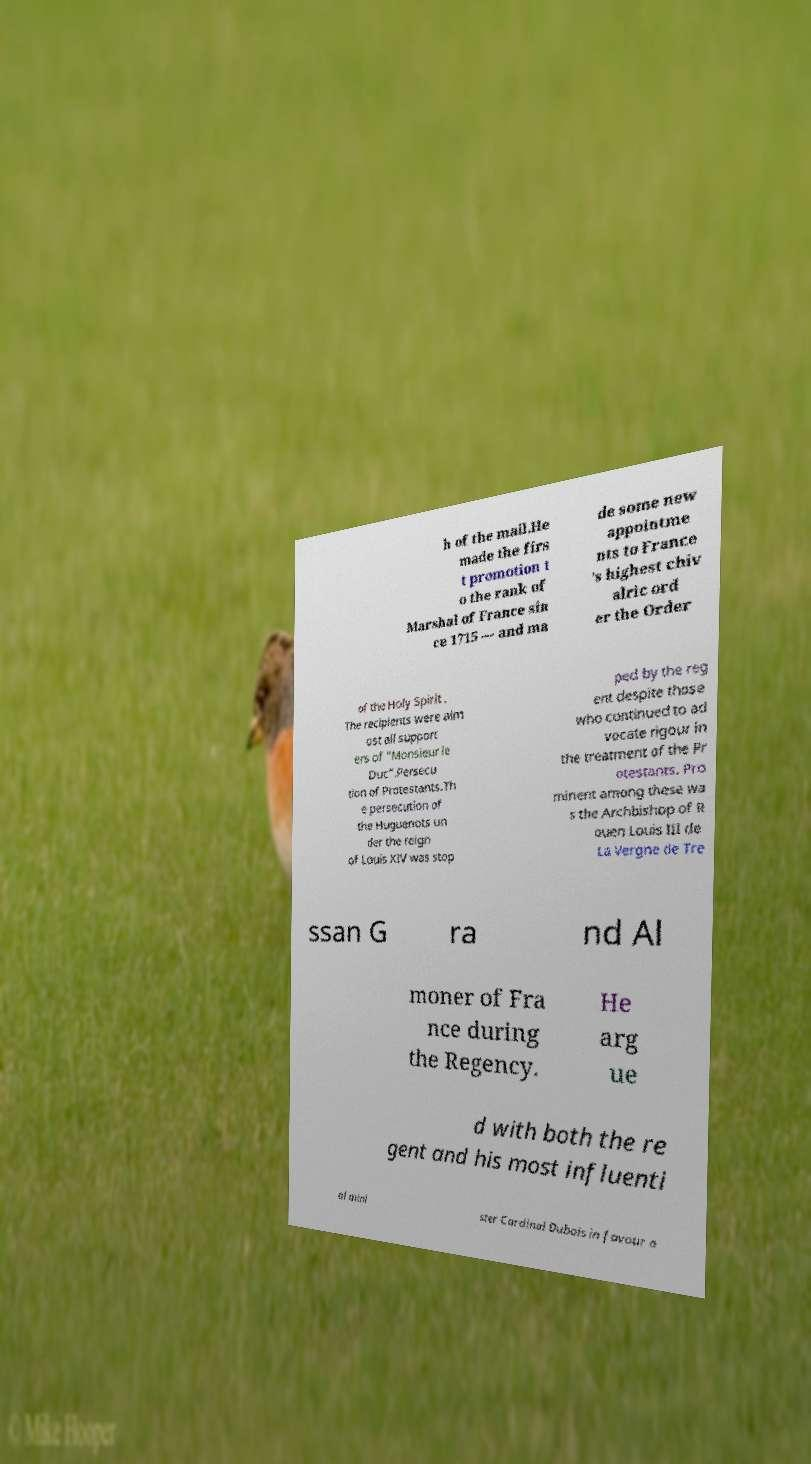What messages or text are displayed in this image? I need them in a readable, typed format. h of the mail.He made the firs t promotion t o the rank of Marshal of France sin ce 1715 — and ma de some new appointme nts to France 's highest chiv alric ord er the Order of the Holy Spirit . The recipients were alm ost all support ers of "Monsieur le Duc".Persecu tion of Protestants.Th e persecution of the Huguenots un der the reign of Louis XIV was stop ped by the reg ent despite those who continued to ad vocate rigour in the treatment of the Pr otestants. Pro minent among these wa s the Archbishop of R ouen Louis III de La Vergne de Tre ssan G ra nd Al moner of Fra nce during the Regency. He arg ue d with both the re gent and his most influenti al mini ster Cardinal Dubois in favour o 